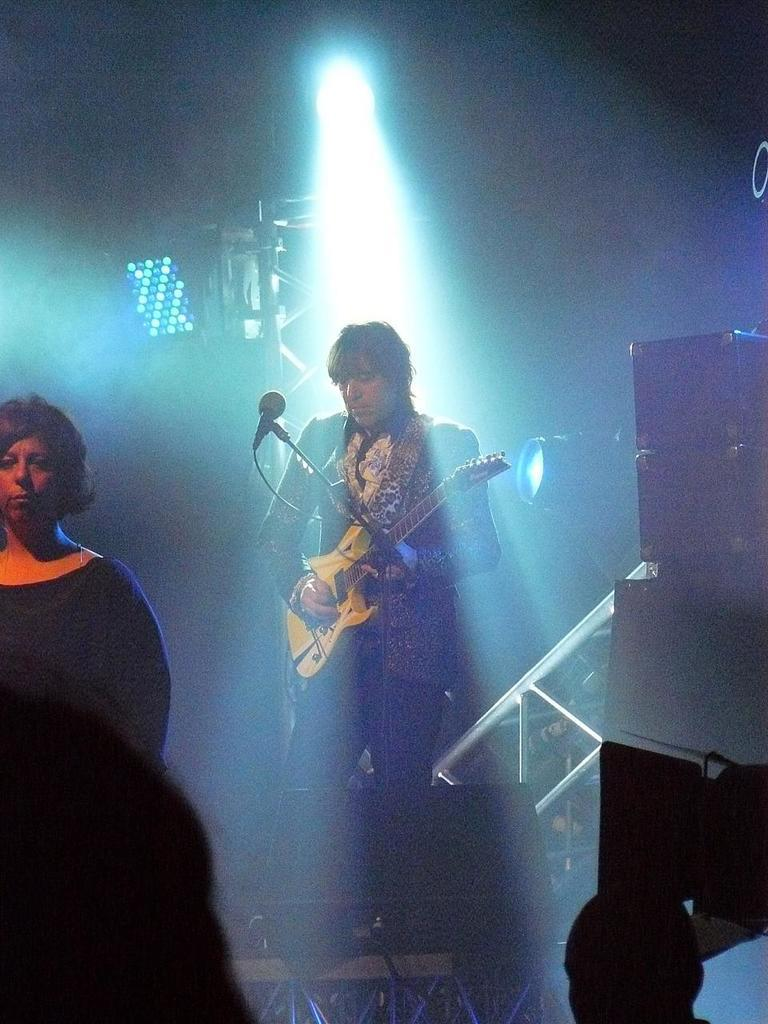What can be seen in the image that provides light? There is a light in the image. How many people are present in the image? There are two people in the image. What is one of the people holding? One of the people is holding a guitar. What position is the person holding the guitar in? The person holding the guitar is standing. What object is in front of the person holding the guitar? There is a microphone in front of the person holding the guitar. Can you see any tickets on the ground near the person holding the guitar? There is no mention of tickets in the image, so we cannot determine if any are present. 